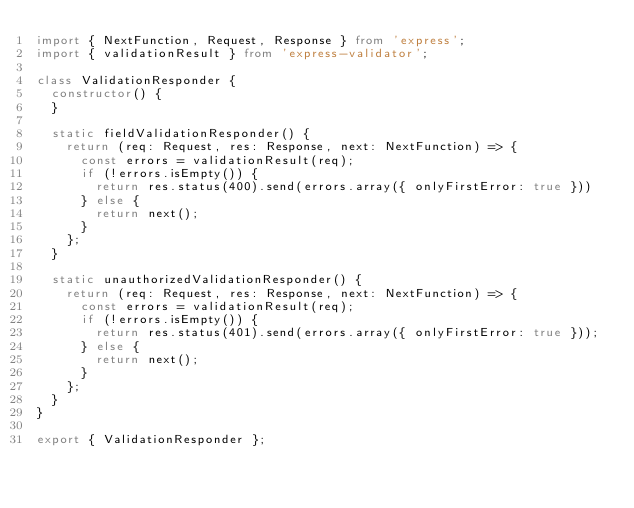Convert code to text. <code><loc_0><loc_0><loc_500><loc_500><_TypeScript_>import { NextFunction, Request, Response } from 'express';
import { validationResult } from 'express-validator';

class ValidationResponder {
  constructor() {
  }

  static fieldValidationResponder() {
    return (req: Request, res: Response, next: NextFunction) => {
      const errors = validationResult(req);
      if (!errors.isEmpty()) {
        return res.status(400).send(errors.array({ onlyFirstError: true }))
      } else {
        return next();
      }
    };
  }

  static unauthorizedValidationResponder() {
    return (req: Request, res: Response, next: NextFunction) => {
      const errors = validationResult(req);      
      if (!errors.isEmpty()) {
        return res.status(401).send(errors.array({ onlyFirstError: true }));
      } else {
        return next();
      }
    };
  }
}

export { ValidationResponder };
</code> 